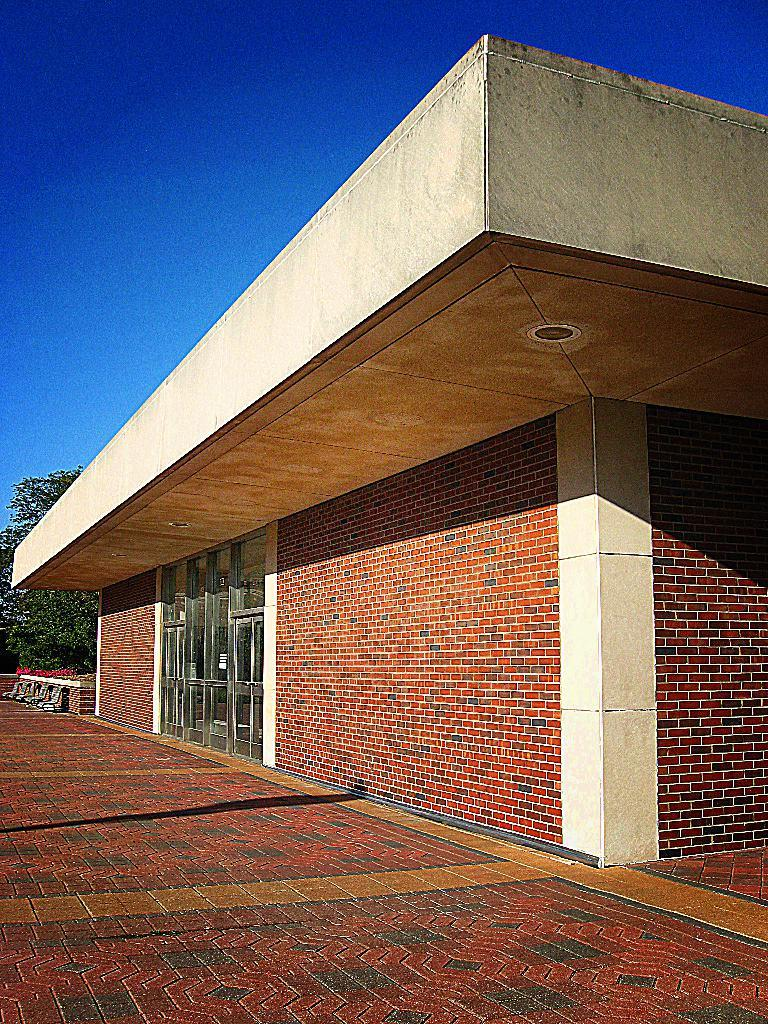What type of structure is visible in the image? There is a building in the image. What can be seen in the background of the image? There are trees in the background of the image. What type of farm animals can be seen in the image? There are no farm animals present in the image; it only features a building and trees in the background. 